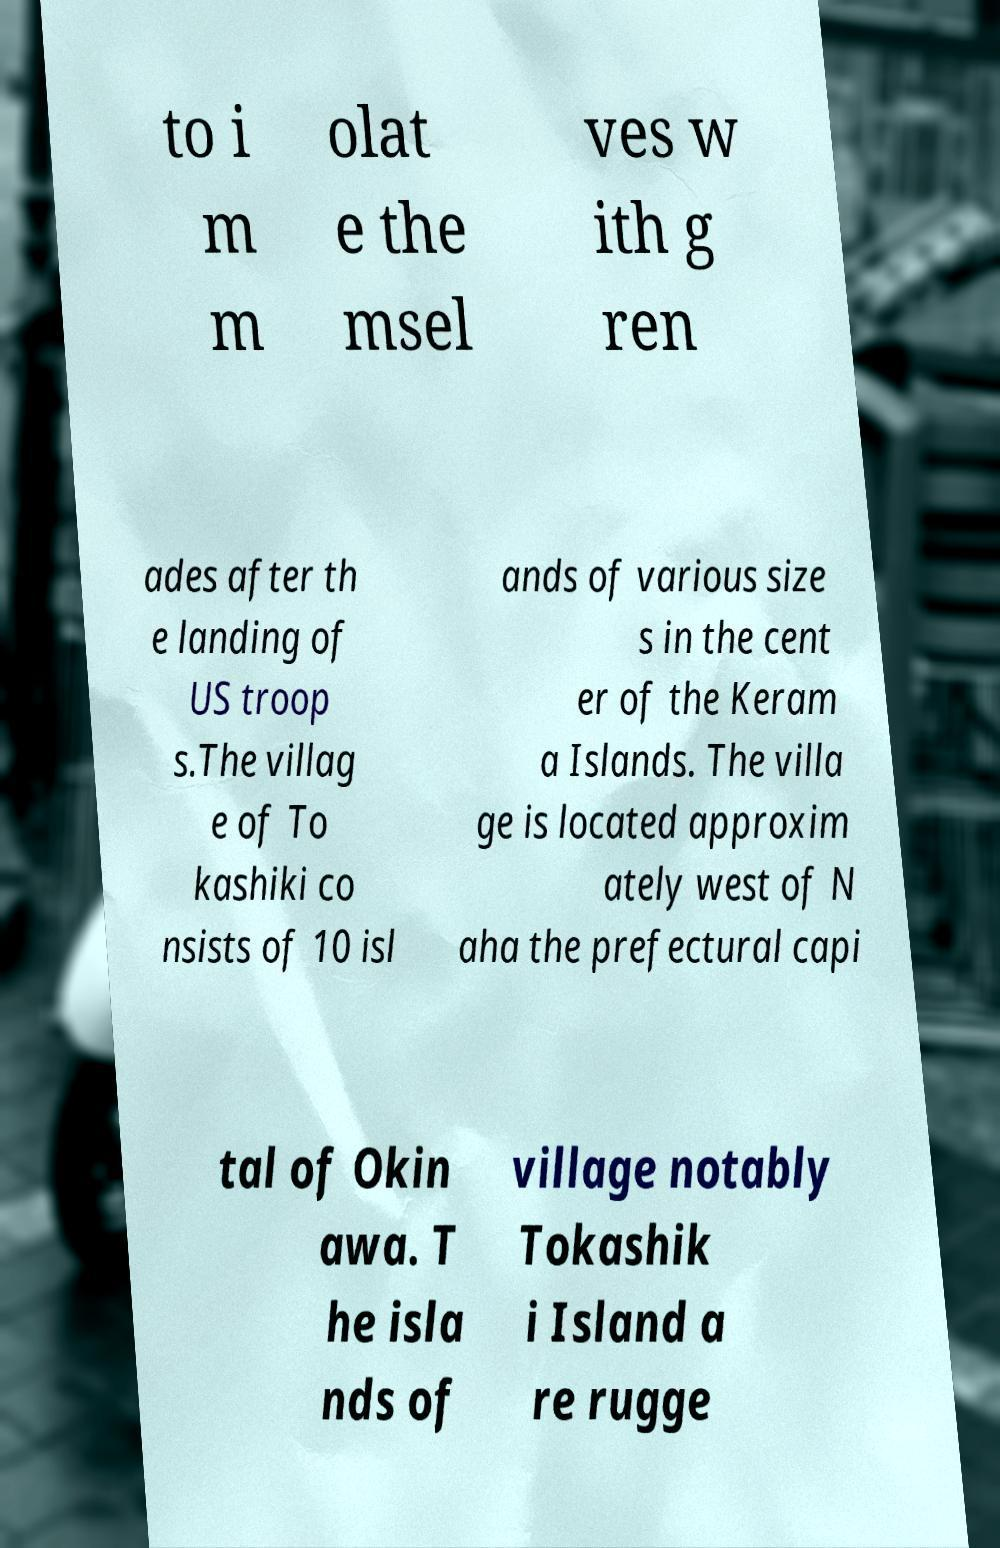Please read and relay the text visible in this image. What does it say? to i m m olat e the msel ves w ith g ren ades after th e landing of US troop s.The villag e of To kashiki co nsists of 10 isl ands of various size s in the cent er of the Keram a Islands. The villa ge is located approxim ately west of N aha the prefectural capi tal of Okin awa. T he isla nds of village notably Tokashik i Island a re rugge 